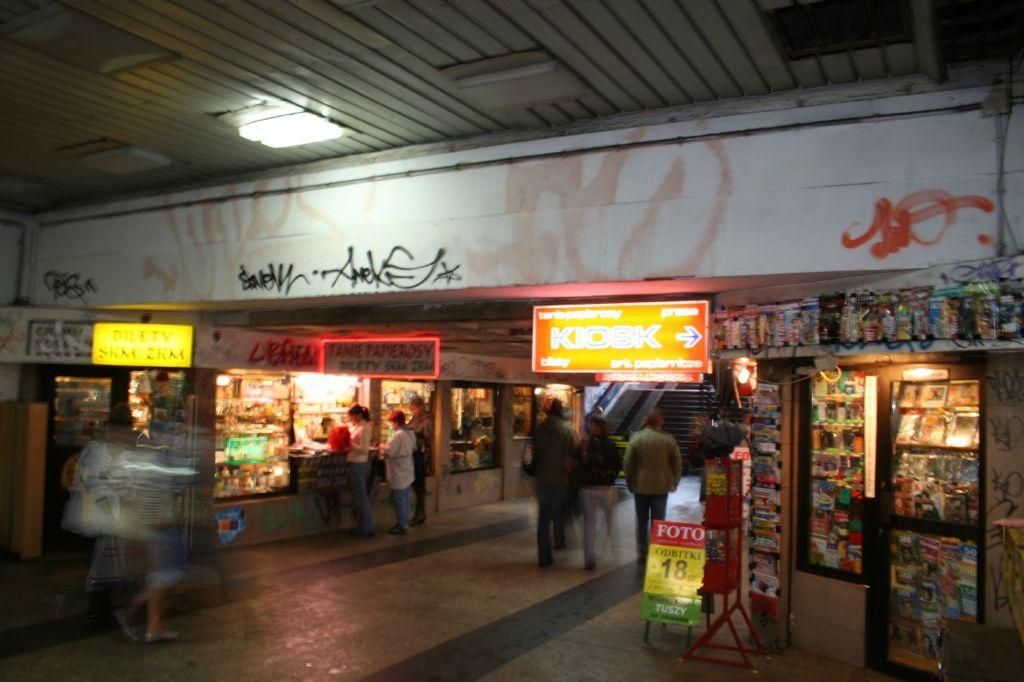<image>
Describe the image concisely. an orange Kiosk written on a sign with graffiti nearby 